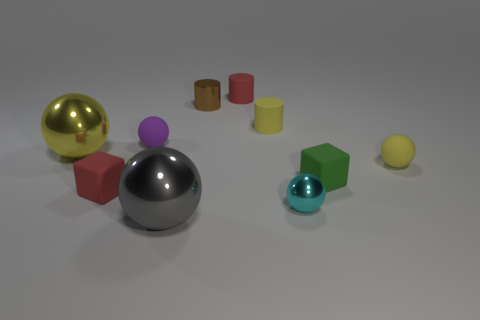Subtract all rubber balls. How many balls are left? 3 Subtract all yellow cylinders. How many cylinders are left? 2 Subtract all cylinders. How many objects are left? 7 Subtract 2 cylinders. How many cylinders are left? 1 Subtract all brown balls. How many cyan cylinders are left? 0 Subtract all yellow matte balls. Subtract all tiny brown things. How many objects are left? 8 Add 7 brown objects. How many brown objects are left? 8 Add 1 big yellow balls. How many big yellow balls exist? 2 Subtract 1 cyan spheres. How many objects are left? 9 Subtract all gray cylinders. Subtract all yellow balls. How many cylinders are left? 3 